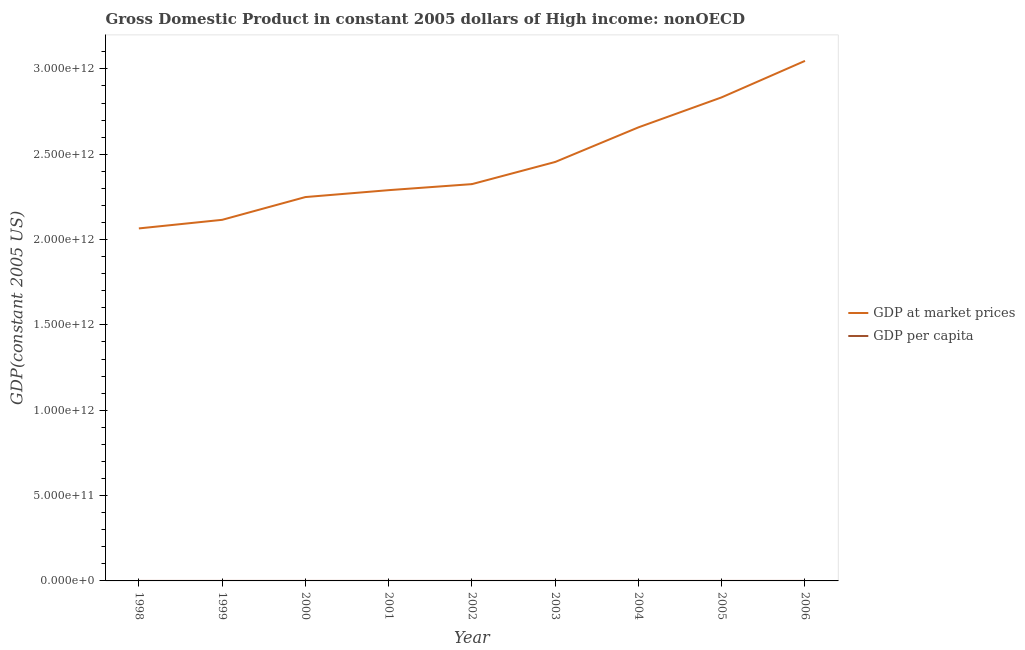Does the line corresponding to gdp per capita intersect with the line corresponding to gdp at market prices?
Ensure brevity in your answer.  No. What is the gdp per capita in 2002?
Provide a short and direct response. 7811.08. Across all years, what is the maximum gdp per capita?
Give a very brief answer. 9979.39. Across all years, what is the minimum gdp per capita?
Offer a terse response. 7080.11. In which year was the gdp per capita maximum?
Offer a terse response. 2006. In which year was the gdp per capita minimum?
Give a very brief answer. 1998. What is the total gdp at market prices in the graph?
Provide a short and direct response. 2.20e+13. What is the difference between the gdp at market prices in 2001 and that in 2002?
Provide a succinct answer. -3.54e+1. What is the difference between the gdp at market prices in 2003 and the gdp per capita in 2006?
Offer a very short reply. 2.45e+12. What is the average gdp at market prices per year?
Make the answer very short. 2.45e+12. In the year 2000, what is the difference between the gdp at market prices and gdp per capita?
Your response must be concise. 2.25e+12. What is the ratio of the gdp at market prices in 2001 to that in 2005?
Your response must be concise. 0.81. Is the difference between the gdp at market prices in 2003 and 2004 greater than the difference between the gdp per capita in 2003 and 2004?
Make the answer very short. No. What is the difference between the highest and the second highest gdp at market prices?
Provide a short and direct response. 2.14e+11. What is the difference between the highest and the lowest gdp at market prices?
Provide a short and direct response. 9.82e+11. In how many years, is the gdp per capita greater than the average gdp per capita taken over all years?
Keep it short and to the point. 4. Is the gdp per capita strictly greater than the gdp at market prices over the years?
Make the answer very short. No. Is the gdp at market prices strictly less than the gdp per capita over the years?
Your answer should be compact. No. How many lines are there?
Ensure brevity in your answer.  2. How many years are there in the graph?
Your response must be concise. 9. What is the difference between two consecutive major ticks on the Y-axis?
Provide a succinct answer. 5.00e+11. What is the title of the graph?
Your response must be concise. Gross Domestic Product in constant 2005 dollars of High income: nonOECD. Does "Boys" appear as one of the legend labels in the graph?
Give a very brief answer. No. What is the label or title of the X-axis?
Provide a succinct answer. Year. What is the label or title of the Y-axis?
Ensure brevity in your answer.  GDP(constant 2005 US). What is the GDP(constant 2005 US) in GDP at market prices in 1998?
Ensure brevity in your answer.  2.07e+12. What is the GDP(constant 2005 US) in GDP per capita in 1998?
Offer a very short reply. 7080.11. What is the GDP(constant 2005 US) in GDP at market prices in 1999?
Your answer should be compact. 2.12e+12. What is the GDP(constant 2005 US) in GDP per capita in 1999?
Provide a short and direct response. 7212.98. What is the GDP(constant 2005 US) of GDP at market prices in 2000?
Your response must be concise. 2.25e+12. What is the GDP(constant 2005 US) in GDP per capita in 2000?
Your response must be concise. 7632.8. What is the GDP(constant 2005 US) in GDP at market prices in 2001?
Give a very brief answer. 2.29e+12. What is the GDP(constant 2005 US) of GDP per capita in 2001?
Offer a terse response. 7729.38. What is the GDP(constant 2005 US) in GDP at market prices in 2002?
Offer a very short reply. 2.32e+12. What is the GDP(constant 2005 US) in GDP per capita in 2002?
Offer a very short reply. 7811.08. What is the GDP(constant 2005 US) in GDP at market prices in 2003?
Your answer should be compact. 2.45e+12. What is the GDP(constant 2005 US) of GDP per capita in 2003?
Your response must be concise. 8208.92. What is the GDP(constant 2005 US) in GDP at market prices in 2004?
Your response must be concise. 2.66e+12. What is the GDP(constant 2005 US) in GDP per capita in 2004?
Provide a succinct answer. 8834.08. What is the GDP(constant 2005 US) of GDP at market prices in 2005?
Your answer should be compact. 2.83e+12. What is the GDP(constant 2005 US) of GDP per capita in 2005?
Keep it short and to the point. 9354.6. What is the GDP(constant 2005 US) in GDP at market prices in 2006?
Your answer should be compact. 3.05e+12. What is the GDP(constant 2005 US) of GDP per capita in 2006?
Offer a very short reply. 9979.39. Across all years, what is the maximum GDP(constant 2005 US) in GDP at market prices?
Your answer should be compact. 3.05e+12. Across all years, what is the maximum GDP(constant 2005 US) in GDP per capita?
Ensure brevity in your answer.  9979.39. Across all years, what is the minimum GDP(constant 2005 US) in GDP at market prices?
Your response must be concise. 2.07e+12. Across all years, what is the minimum GDP(constant 2005 US) of GDP per capita?
Provide a succinct answer. 7080.11. What is the total GDP(constant 2005 US) in GDP at market prices in the graph?
Provide a succinct answer. 2.20e+13. What is the total GDP(constant 2005 US) in GDP per capita in the graph?
Offer a terse response. 7.38e+04. What is the difference between the GDP(constant 2005 US) of GDP at market prices in 1998 and that in 1999?
Offer a very short reply. -5.03e+1. What is the difference between the GDP(constant 2005 US) in GDP per capita in 1998 and that in 1999?
Give a very brief answer. -132.87. What is the difference between the GDP(constant 2005 US) of GDP at market prices in 1998 and that in 2000?
Provide a short and direct response. -1.84e+11. What is the difference between the GDP(constant 2005 US) in GDP per capita in 1998 and that in 2000?
Offer a very short reply. -552.69. What is the difference between the GDP(constant 2005 US) of GDP at market prices in 1998 and that in 2001?
Keep it short and to the point. -2.24e+11. What is the difference between the GDP(constant 2005 US) of GDP per capita in 1998 and that in 2001?
Your response must be concise. -649.27. What is the difference between the GDP(constant 2005 US) of GDP at market prices in 1998 and that in 2002?
Provide a short and direct response. -2.60e+11. What is the difference between the GDP(constant 2005 US) of GDP per capita in 1998 and that in 2002?
Provide a succinct answer. -730.97. What is the difference between the GDP(constant 2005 US) of GDP at market prices in 1998 and that in 2003?
Offer a terse response. -3.89e+11. What is the difference between the GDP(constant 2005 US) in GDP per capita in 1998 and that in 2003?
Give a very brief answer. -1128.81. What is the difference between the GDP(constant 2005 US) of GDP at market prices in 1998 and that in 2004?
Provide a succinct answer. -5.92e+11. What is the difference between the GDP(constant 2005 US) in GDP per capita in 1998 and that in 2004?
Give a very brief answer. -1753.97. What is the difference between the GDP(constant 2005 US) of GDP at market prices in 1998 and that in 2005?
Give a very brief answer. -7.68e+11. What is the difference between the GDP(constant 2005 US) of GDP per capita in 1998 and that in 2005?
Your response must be concise. -2274.49. What is the difference between the GDP(constant 2005 US) of GDP at market prices in 1998 and that in 2006?
Offer a terse response. -9.82e+11. What is the difference between the GDP(constant 2005 US) of GDP per capita in 1998 and that in 2006?
Offer a terse response. -2899.28. What is the difference between the GDP(constant 2005 US) in GDP at market prices in 1999 and that in 2000?
Ensure brevity in your answer.  -1.33e+11. What is the difference between the GDP(constant 2005 US) in GDP per capita in 1999 and that in 2000?
Make the answer very short. -419.82. What is the difference between the GDP(constant 2005 US) in GDP at market prices in 1999 and that in 2001?
Offer a very short reply. -1.74e+11. What is the difference between the GDP(constant 2005 US) of GDP per capita in 1999 and that in 2001?
Ensure brevity in your answer.  -516.4. What is the difference between the GDP(constant 2005 US) of GDP at market prices in 1999 and that in 2002?
Give a very brief answer. -2.09e+11. What is the difference between the GDP(constant 2005 US) of GDP per capita in 1999 and that in 2002?
Offer a terse response. -598.09. What is the difference between the GDP(constant 2005 US) of GDP at market prices in 1999 and that in 2003?
Provide a short and direct response. -3.39e+11. What is the difference between the GDP(constant 2005 US) in GDP per capita in 1999 and that in 2003?
Make the answer very short. -995.94. What is the difference between the GDP(constant 2005 US) of GDP at market prices in 1999 and that in 2004?
Provide a succinct answer. -5.42e+11. What is the difference between the GDP(constant 2005 US) in GDP per capita in 1999 and that in 2004?
Your answer should be very brief. -1621.09. What is the difference between the GDP(constant 2005 US) of GDP at market prices in 1999 and that in 2005?
Offer a very short reply. -7.18e+11. What is the difference between the GDP(constant 2005 US) of GDP per capita in 1999 and that in 2005?
Offer a terse response. -2141.62. What is the difference between the GDP(constant 2005 US) of GDP at market prices in 1999 and that in 2006?
Keep it short and to the point. -9.31e+11. What is the difference between the GDP(constant 2005 US) of GDP per capita in 1999 and that in 2006?
Make the answer very short. -2766.41. What is the difference between the GDP(constant 2005 US) in GDP at market prices in 2000 and that in 2001?
Give a very brief answer. -4.05e+1. What is the difference between the GDP(constant 2005 US) of GDP per capita in 2000 and that in 2001?
Give a very brief answer. -96.58. What is the difference between the GDP(constant 2005 US) of GDP at market prices in 2000 and that in 2002?
Give a very brief answer. -7.58e+1. What is the difference between the GDP(constant 2005 US) in GDP per capita in 2000 and that in 2002?
Offer a very short reply. -178.28. What is the difference between the GDP(constant 2005 US) in GDP at market prices in 2000 and that in 2003?
Your answer should be compact. -2.06e+11. What is the difference between the GDP(constant 2005 US) of GDP per capita in 2000 and that in 2003?
Offer a terse response. -576.12. What is the difference between the GDP(constant 2005 US) in GDP at market prices in 2000 and that in 2004?
Your answer should be compact. -4.08e+11. What is the difference between the GDP(constant 2005 US) of GDP per capita in 2000 and that in 2004?
Make the answer very short. -1201.28. What is the difference between the GDP(constant 2005 US) in GDP at market prices in 2000 and that in 2005?
Ensure brevity in your answer.  -5.84e+11. What is the difference between the GDP(constant 2005 US) of GDP per capita in 2000 and that in 2005?
Offer a terse response. -1721.8. What is the difference between the GDP(constant 2005 US) in GDP at market prices in 2000 and that in 2006?
Your answer should be very brief. -7.98e+11. What is the difference between the GDP(constant 2005 US) in GDP per capita in 2000 and that in 2006?
Provide a succinct answer. -2346.59. What is the difference between the GDP(constant 2005 US) in GDP at market prices in 2001 and that in 2002?
Give a very brief answer. -3.54e+1. What is the difference between the GDP(constant 2005 US) in GDP per capita in 2001 and that in 2002?
Offer a very short reply. -81.69. What is the difference between the GDP(constant 2005 US) of GDP at market prices in 2001 and that in 2003?
Provide a succinct answer. -1.65e+11. What is the difference between the GDP(constant 2005 US) of GDP per capita in 2001 and that in 2003?
Keep it short and to the point. -479.54. What is the difference between the GDP(constant 2005 US) of GDP at market prices in 2001 and that in 2004?
Ensure brevity in your answer.  -3.68e+11. What is the difference between the GDP(constant 2005 US) of GDP per capita in 2001 and that in 2004?
Keep it short and to the point. -1104.69. What is the difference between the GDP(constant 2005 US) in GDP at market prices in 2001 and that in 2005?
Make the answer very short. -5.44e+11. What is the difference between the GDP(constant 2005 US) of GDP per capita in 2001 and that in 2005?
Offer a terse response. -1625.22. What is the difference between the GDP(constant 2005 US) in GDP at market prices in 2001 and that in 2006?
Your answer should be compact. -7.57e+11. What is the difference between the GDP(constant 2005 US) in GDP per capita in 2001 and that in 2006?
Make the answer very short. -2250.01. What is the difference between the GDP(constant 2005 US) of GDP at market prices in 2002 and that in 2003?
Ensure brevity in your answer.  -1.30e+11. What is the difference between the GDP(constant 2005 US) of GDP per capita in 2002 and that in 2003?
Keep it short and to the point. -397.84. What is the difference between the GDP(constant 2005 US) in GDP at market prices in 2002 and that in 2004?
Provide a succinct answer. -3.33e+11. What is the difference between the GDP(constant 2005 US) in GDP per capita in 2002 and that in 2004?
Your response must be concise. -1023. What is the difference between the GDP(constant 2005 US) of GDP at market prices in 2002 and that in 2005?
Provide a succinct answer. -5.09e+11. What is the difference between the GDP(constant 2005 US) in GDP per capita in 2002 and that in 2005?
Keep it short and to the point. -1543.52. What is the difference between the GDP(constant 2005 US) in GDP at market prices in 2002 and that in 2006?
Your answer should be compact. -7.22e+11. What is the difference between the GDP(constant 2005 US) in GDP per capita in 2002 and that in 2006?
Your answer should be compact. -2168.31. What is the difference between the GDP(constant 2005 US) in GDP at market prices in 2003 and that in 2004?
Provide a short and direct response. -2.03e+11. What is the difference between the GDP(constant 2005 US) in GDP per capita in 2003 and that in 2004?
Provide a short and direct response. -625.16. What is the difference between the GDP(constant 2005 US) of GDP at market prices in 2003 and that in 2005?
Make the answer very short. -3.79e+11. What is the difference between the GDP(constant 2005 US) of GDP per capita in 2003 and that in 2005?
Your answer should be compact. -1145.68. What is the difference between the GDP(constant 2005 US) of GDP at market prices in 2003 and that in 2006?
Offer a terse response. -5.92e+11. What is the difference between the GDP(constant 2005 US) of GDP per capita in 2003 and that in 2006?
Offer a terse response. -1770.47. What is the difference between the GDP(constant 2005 US) of GDP at market prices in 2004 and that in 2005?
Your answer should be compact. -1.76e+11. What is the difference between the GDP(constant 2005 US) in GDP per capita in 2004 and that in 2005?
Your response must be concise. -520.52. What is the difference between the GDP(constant 2005 US) in GDP at market prices in 2004 and that in 2006?
Offer a very short reply. -3.89e+11. What is the difference between the GDP(constant 2005 US) in GDP per capita in 2004 and that in 2006?
Your answer should be very brief. -1145.31. What is the difference between the GDP(constant 2005 US) of GDP at market prices in 2005 and that in 2006?
Your answer should be compact. -2.14e+11. What is the difference between the GDP(constant 2005 US) of GDP per capita in 2005 and that in 2006?
Give a very brief answer. -624.79. What is the difference between the GDP(constant 2005 US) of GDP at market prices in 1998 and the GDP(constant 2005 US) of GDP per capita in 1999?
Offer a terse response. 2.07e+12. What is the difference between the GDP(constant 2005 US) in GDP at market prices in 1998 and the GDP(constant 2005 US) in GDP per capita in 2000?
Your answer should be very brief. 2.07e+12. What is the difference between the GDP(constant 2005 US) in GDP at market prices in 1998 and the GDP(constant 2005 US) in GDP per capita in 2001?
Provide a short and direct response. 2.07e+12. What is the difference between the GDP(constant 2005 US) in GDP at market prices in 1998 and the GDP(constant 2005 US) in GDP per capita in 2002?
Ensure brevity in your answer.  2.07e+12. What is the difference between the GDP(constant 2005 US) of GDP at market prices in 1998 and the GDP(constant 2005 US) of GDP per capita in 2003?
Offer a very short reply. 2.07e+12. What is the difference between the GDP(constant 2005 US) in GDP at market prices in 1998 and the GDP(constant 2005 US) in GDP per capita in 2004?
Keep it short and to the point. 2.07e+12. What is the difference between the GDP(constant 2005 US) of GDP at market prices in 1998 and the GDP(constant 2005 US) of GDP per capita in 2005?
Offer a very short reply. 2.07e+12. What is the difference between the GDP(constant 2005 US) in GDP at market prices in 1998 and the GDP(constant 2005 US) in GDP per capita in 2006?
Provide a succinct answer. 2.07e+12. What is the difference between the GDP(constant 2005 US) of GDP at market prices in 1999 and the GDP(constant 2005 US) of GDP per capita in 2000?
Your answer should be compact. 2.12e+12. What is the difference between the GDP(constant 2005 US) of GDP at market prices in 1999 and the GDP(constant 2005 US) of GDP per capita in 2001?
Your answer should be very brief. 2.12e+12. What is the difference between the GDP(constant 2005 US) in GDP at market prices in 1999 and the GDP(constant 2005 US) in GDP per capita in 2002?
Your answer should be compact. 2.12e+12. What is the difference between the GDP(constant 2005 US) of GDP at market prices in 1999 and the GDP(constant 2005 US) of GDP per capita in 2003?
Your answer should be compact. 2.12e+12. What is the difference between the GDP(constant 2005 US) in GDP at market prices in 1999 and the GDP(constant 2005 US) in GDP per capita in 2004?
Make the answer very short. 2.12e+12. What is the difference between the GDP(constant 2005 US) in GDP at market prices in 1999 and the GDP(constant 2005 US) in GDP per capita in 2005?
Make the answer very short. 2.12e+12. What is the difference between the GDP(constant 2005 US) in GDP at market prices in 1999 and the GDP(constant 2005 US) in GDP per capita in 2006?
Offer a very short reply. 2.12e+12. What is the difference between the GDP(constant 2005 US) in GDP at market prices in 2000 and the GDP(constant 2005 US) in GDP per capita in 2001?
Offer a very short reply. 2.25e+12. What is the difference between the GDP(constant 2005 US) in GDP at market prices in 2000 and the GDP(constant 2005 US) in GDP per capita in 2002?
Offer a terse response. 2.25e+12. What is the difference between the GDP(constant 2005 US) of GDP at market prices in 2000 and the GDP(constant 2005 US) of GDP per capita in 2003?
Your answer should be compact. 2.25e+12. What is the difference between the GDP(constant 2005 US) of GDP at market prices in 2000 and the GDP(constant 2005 US) of GDP per capita in 2004?
Your answer should be compact. 2.25e+12. What is the difference between the GDP(constant 2005 US) in GDP at market prices in 2000 and the GDP(constant 2005 US) in GDP per capita in 2005?
Keep it short and to the point. 2.25e+12. What is the difference between the GDP(constant 2005 US) in GDP at market prices in 2000 and the GDP(constant 2005 US) in GDP per capita in 2006?
Offer a terse response. 2.25e+12. What is the difference between the GDP(constant 2005 US) of GDP at market prices in 2001 and the GDP(constant 2005 US) of GDP per capita in 2002?
Your answer should be very brief. 2.29e+12. What is the difference between the GDP(constant 2005 US) of GDP at market prices in 2001 and the GDP(constant 2005 US) of GDP per capita in 2003?
Make the answer very short. 2.29e+12. What is the difference between the GDP(constant 2005 US) of GDP at market prices in 2001 and the GDP(constant 2005 US) of GDP per capita in 2004?
Make the answer very short. 2.29e+12. What is the difference between the GDP(constant 2005 US) in GDP at market prices in 2001 and the GDP(constant 2005 US) in GDP per capita in 2005?
Your answer should be very brief. 2.29e+12. What is the difference between the GDP(constant 2005 US) in GDP at market prices in 2001 and the GDP(constant 2005 US) in GDP per capita in 2006?
Offer a terse response. 2.29e+12. What is the difference between the GDP(constant 2005 US) of GDP at market prices in 2002 and the GDP(constant 2005 US) of GDP per capita in 2003?
Keep it short and to the point. 2.32e+12. What is the difference between the GDP(constant 2005 US) of GDP at market prices in 2002 and the GDP(constant 2005 US) of GDP per capita in 2004?
Your answer should be very brief. 2.32e+12. What is the difference between the GDP(constant 2005 US) of GDP at market prices in 2002 and the GDP(constant 2005 US) of GDP per capita in 2005?
Give a very brief answer. 2.32e+12. What is the difference between the GDP(constant 2005 US) in GDP at market prices in 2002 and the GDP(constant 2005 US) in GDP per capita in 2006?
Provide a short and direct response. 2.32e+12. What is the difference between the GDP(constant 2005 US) of GDP at market prices in 2003 and the GDP(constant 2005 US) of GDP per capita in 2004?
Keep it short and to the point. 2.45e+12. What is the difference between the GDP(constant 2005 US) of GDP at market prices in 2003 and the GDP(constant 2005 US) of GDP per capita in 2005?
Provide a short and direct response. 2.45e+12. What is the difference between the GDP(constant 2005 US) in GDP at market prices in 2003 and the GDP(constant 2005 US) in GDP per capita in 2006?
Ensure brevity in your answer.  2.45e+12. What is the difference between the GDP(constant 2005 US) of GDP at market prices in 2004 and the GDP(constant 2005 US) of GDP per capita in 2005?
Keep it short and to the point. 2.66e+12. What is the difference between the GDP(constant 2005 US) in GDP at market prices in 2004 and the GDP(constant 2005 US) in GDP per capita in 2006?
Keep it short and to the point. 2.66e+12. What is the difference between the GDP(constant 2005 US) in GDP at market prices in 2005 and the GDP(constant 2005 US) in GDP per capita in 2006?
Offer a very short reply. 2.83e+12. What is the average GDP(constant 2005 US) of GDP at market prices per year?
Your answer should be very brief. 2.45e+12. What is the average GDP(constant 2005 US) of GDP per capita per year?
Offer a very short reply. 8204.82. In the year 1998, what is the difference between the GDP(constant 2005 US) in GDP at market prices and GDP(constant 2005 US) in GDP per capita?
Ensure brevity in your answer.  2.07e+12. In the year 1999, what is the difference between the GDP(constant 2005 US) of GDP at market prices and GDP(constant 2005 US) of GDP per capita?
Give a very brief answer. 2.12e+12. In the year 2000, what is the difference between the GDP(constant 2005 US) in GDP at market prices and GDP(constant 2005 US) in GDP per capita?
Provide a short and direct response. 2.25e+12. In the year 2001, what is the difference between the GDP(constant 2005 US) in GDP at market prices and GDP(constant 2005 US) in GDP per capita?
Offer a terse response. 2.29e+12. In the year 2002, what is the difference between the GDP(constant 2005 US) in GDP at market prices and GDP(constant 2005 US) in GDP per capita?
Provide a succinct answer. 2.32e+12. In the year 2003, what is the difference between the GDP(constant 2005 US) in GDP at market prices and GDP(constant 2005 US) in GDP per capita?
Provide a succinct answer. 2.45e+12. In the year 2004, what is the difference between the GDP(constant 2005 US) of GDP at market prices and GDP(constant 2005 US) of GDP per capita?
Provide a short and direct response. 2.66e+12. In the year 2005, what is the difference between the GDP(constant 2005 US) in GDP at market prices and GDP(constant 2005 US) in GDP per capita?
Your answer should be very brief. 2.83e+12. In the year 2006, what is the difference between the GDP(constant 2005 US) in GDP at market prices and GDP(constant 2005 US) in GDP per capita?
Offer a very short reply. 3.05e+12. What is the ratio of the GDP(constant 2005 US) in GDP at market prices in 1998 to that in 1999?
Your answer should be very brief. 0.98. What is the ratio of the GDP(constant 2005 US) in GDP per capita in 1998 to that in 1999?
Provide a short and direct response. 0.98. What is the ratio of the GDP(constant 2005 US) of GDP at market prices in 1998 to that in 2000?
Provide a succinct answer. 0.92. What is the ratio of the GDP(constant 2005 US) in GDP per capita in 1998 to that in 2000?
Offer a terse response. 0.93. What is the ratio of the GDP(constant 2005 US) in GDP at market prices in 1998 to that in 2001?
Your answer should be very brief. 0.9. What is the ratio of the GDP(constant 2005 US) in GDP per capita in 1998 to that in 2001?
Your answer should be compact. 0.92. What is the ratio of the GDP(constant 2005 US) in GDP at market prices in 1998 to that in 2002?
Your answer should be very brief. 0.89. What is the ratio of the GDP(constant 2005 US) of GDP per capita in 1998 to that in 2002?
Offer a terse response. 0.91. What is the ratio of the GDP(constant 2005 US) of GDP at market prices in 1998 to that in 2003?
Your answer should be very brief. 0.84. What is the ratio of the GDP(constant 2005 US) in GDP per capita in 1998 to that in 2003?
Your response must be concise. 0.86. What is the ratio of the GDP(constant 2005 US) of GDP at market prices in 1998 to that in 2004?
Give a very brief answer. 0.78. What is the ratio of the GDP(constant 2005 US) in GDP per capita in 1998 to that in 2004?
Your answer should be compact. 0.8. What is the ratio of the GDP(constant 2005 US) in GDP at market prices in 1998 to that in 2005?
Your answer should be compact. 0.73. What is the ratio of the GDP(constant 2005 US) in GDP per capita in 1998 to that in 2005?
Your answer should be very brief. 0.76. What is the ratio of the GDP(constant 2005 US) of GDP at market prices in 1998 to that in 2006?
Give a very brief answer. 0.68. What is the ratio of the GDP(constant 2005 US) in GDP per capita in 1998 to that in 2006?
Provide a short and direct response. 0.71. What is the ratio of the GDP(constant 2005 US) of GDP at market prices in 1999 to that in 2000?
Provide a short and direct response. 0.94. What is the ratio of the GDP(constant 2005 US) of GDP per capita in 1999 to that in 2000?
Provide a short and direct response. 0.94. What is the ratio of the GDP(constant 2005 US) of GDP at market prices in 1999 to that in 2001?
Your response must be concise. 0.92. What is the ratio of the GDP(constant 2005 US) of GDP per capita in 1999 to that in 2001?
Make the answer very short. 0.93. What is the ratio of the GDP(constant 2005 US) of GDP at market prices in 1999 to that in 2002?
Offer a very short reply. 0.91. What is the ratio of the GDP(constant 2005 US) of GDP per capita in 1999 to that in 2002?
Offer a terse response. 0.92. What is the ratio of the GDP(constant 2005 US) of GDP at market prices in 1999 to that in 2003?
Provide a short and direct response. 0.86. What is the ratio of the GDP(constant 2005 US) of GDP per capita in 1999 to that in 2003?
Provide a succinct answer. 0.88. What is the ratio of the GDP(constant 2005 US) in GDP at market prices in 1999 to that in 2004?
Ensure brevity in your answer.  0.8. What is the ratio of the GDP(constant 2005 US) of GDP per capita in 1999 to that in 2004?
Your answer should be very brief. 0.82. What is the ratio of the GDP(constant 2005 US) of GDP at market prices in 1999 to that in 2005?
Make the answer very short. 0.75. What is the ratio of the GDP(constant 2005 US) of GDP per capita in 1999 to that in 2005?
Offer a very short reply. 0.77. What is the ratio of the GDP(constant 2005 US) in GDP at market prices in 1999 to that in 2006?
Your answer should be very brief. 0.69. What is the ratio of the GDP(constant 2005 US) in GDP per capita in 1999 to that in 2006?
Offer a terse response. 0.72. What is the ratio of the GDP(constant 2005 US) of GDP at market prices in 2000 to that in 2001?
Provide a short and direct response. 0.98. What is the ratio of the GDP(constant 2005 US) of GDP per capita in 2000 to that in 2001?
Provide a short and direct response. 0.99. What is the ratio of the GDP(constant 2005 US) in GDP at market prices in 2000 to that in 2002?
Your response must be concise. 0.97. What is the ratio of the GDP(constant 2005 US) of GDP per capita in 2000 to that in 2002?
Your response must be concise. 0.98. What is the ratio of the GDP(constant 2005 US) of GDP at market prices in 2000 to that in 2003?
Ensure brevity in your answer.  0.92. What is the ratio of the GDP(constant 2005 US) of GDP per capita in 2000 to that in 2003?
Ensure brevity in your answer.  0.93. What is the ratio of the GDP(constant 2005 US) in GDP at market prices in 2000 to that in 2004?
Provide a succinct answer. 0.85. What is the ratio of the GDP(constant 2005 US) of GDP per capita in 2000 to that in 2004?
Provide a short and direct response. 0.86. What is the ratio of the GDP(constant 2005 US) of GDP at market prices in 2000 to that in 2005?
Your response must be concise. 0.79. What is the ratio of the GDP(constant 2005 US) of GDP per capita in 2000 to that in 2005?
Make the answer very short. 0.82. What is the ratio of the GDP(constant 2005 US) in GDP at market prices in 2000 to that in 2006?
Give a very brief answer. 0.74. What is the ratio of the GDP(constant 2005 US) in GDP per capita in 2000 to that in 2006?
Give a very brief answer. 0.76. What is the ratio of the GDP(constant 2005 US) of GDP at market prices in 2001 to that in 2002?
Your answer should be very brief. 0.98. What is the ratio of the GDP(constant 2005 US) in GDP at market prices in 2001 to that in 2003?
Keep it short and to the point. 0.93. What is the ratio of the GDP(constant 2005 US) in GDP per capita in 2001 to that in 2003?
Give a very brief answer. 0.94. What is the ratio of the GDP(constant 2005 US) in GDP at market prices in 2001 to that in 2004?
Offer a terse response. 0.86. What is the ratio of the GDP(constant 2005 US) of GDP at market prices in 2001 to that in 2005?
Provide a succinct answer. 0.81. What is the ratio of the GDP(constant 2005 US) of GDP per capita in 2001 to that in 2005?
Keep it short and to the point. 0.83. What is the ratio of the GDP(constant 2005 US) of GDP at market prices in 2001 to that in 2006?
Make the answer very short. 0.75. What is the ratio of the GDP(constant 2005 US) in GDP per capita in 2001 to that in 2006?
Give a very brief answer. 0.77. What is the ratio of the GDP(constant 2005 US) in GDP at market prices in 2002 to that in 2003?
Offer a terse response. 0.95. What is the ratio of the GDP(constant 2005 US) of GDP per capita in 2002 to that in 2003?
Keep it short and to the point. 0.95. What is the ratio of the GDP(constant 2005 US) in GDP at market prices in 2002 to that in 2004?
Offer a very short reply. 0.87. What is the ratio of the GDP(constant 2005 US) of GDP per capita in 2002 to that in 2004?
Your answer should be compact. 0.88. What is the ratio of the GDP(constant 2005 US) in GDP at market prices in 2002 to that in 2005?
Ensure brevity in your answer.  0.82. What is the ratio of the GDP(constant 2005 US) of GDP per capita in 2002 to that in 2005?
Ensure brevity in your answer.  0.83. What is the ratio of the GDP(constant 2005 US) of GDP at market prices in 2002 to that in 2006?
Ensure brevity in your answer.  0.76. What is the ratio of the GDP(constant 2005 US) of GDP per capita in 2002 to that in 2006?
Keep it short and to the point. 0.78. What is the ratio of the GDP(constant 2005 US) in GDP at market prices in 2003 to that in 2004?
Ensure brevity in your answer.  0.92. What is the ratio of the GDP(constant 2005 US) of GDP per capita in 2003 to that in 2004?
Your response must be concise. 0.93. What is the ratio of the GDP(constant 2005 US) in GDP at market prices in 2003 to that in 2005?
Offer a terse response. 0.87. What is the ratio of the GDP(constant 2005 US) in GDP per capita in 2003 to that in 2005?
Provide a short and direct response. 0.88. What is the ratio of the GDP(constant 2005 US) in GDP at market prices in 2003 to that in 2006?
Keep it short and to the point. 0.81. What is the ratio of the GDP(constant 2005 US) in GDP per capita in 2003 to that in 2006?
Ensure brevity in your answer.  0.82. What is the ratio of the GDP(constant 2005 US) in GDP at market prices in 2004 to that in 2005?
Provide a succinct answer. 0.94. What is the ratio of the GDP(constant 2005 US) of GDP at market prices in 2004 to that in 2006?
Make the answer very short. 0.87. What is the ratio of the GDP(constant 2005 US) of GDP per capita in 2004 to that in 2006?
Keep it short and to the point. 0.89. What is the ratio of the GDP(constant 2005 US) in GDP at market prices in 2005 to that in 2006?
Provide a succinct answer. 0.93. What is the ratio of the GDP(constant 2005 US) in GDP per capita in 2005 to that in 2006?
Ensure brevity in your answer.  0.94. What is the difference between the highest and the second highest GDP(constant 2005 US) in GDP at market prices?
Your answer should be compact. 2.14e+11. What is the difference between the highest and the second highest GDP(constant 2005 US) of GDP per capita?
Provide a short and direct response. 624.79. What is the difference between the highest and the lowest GDP(constant 2005 US) in GDP at market prices?
Offer a terse response. 9.82e+11. What is the difference between the highest and the lowest GDP(constant 2005 US) in GDP per capita?
Offer a terse response. 2899.28. 